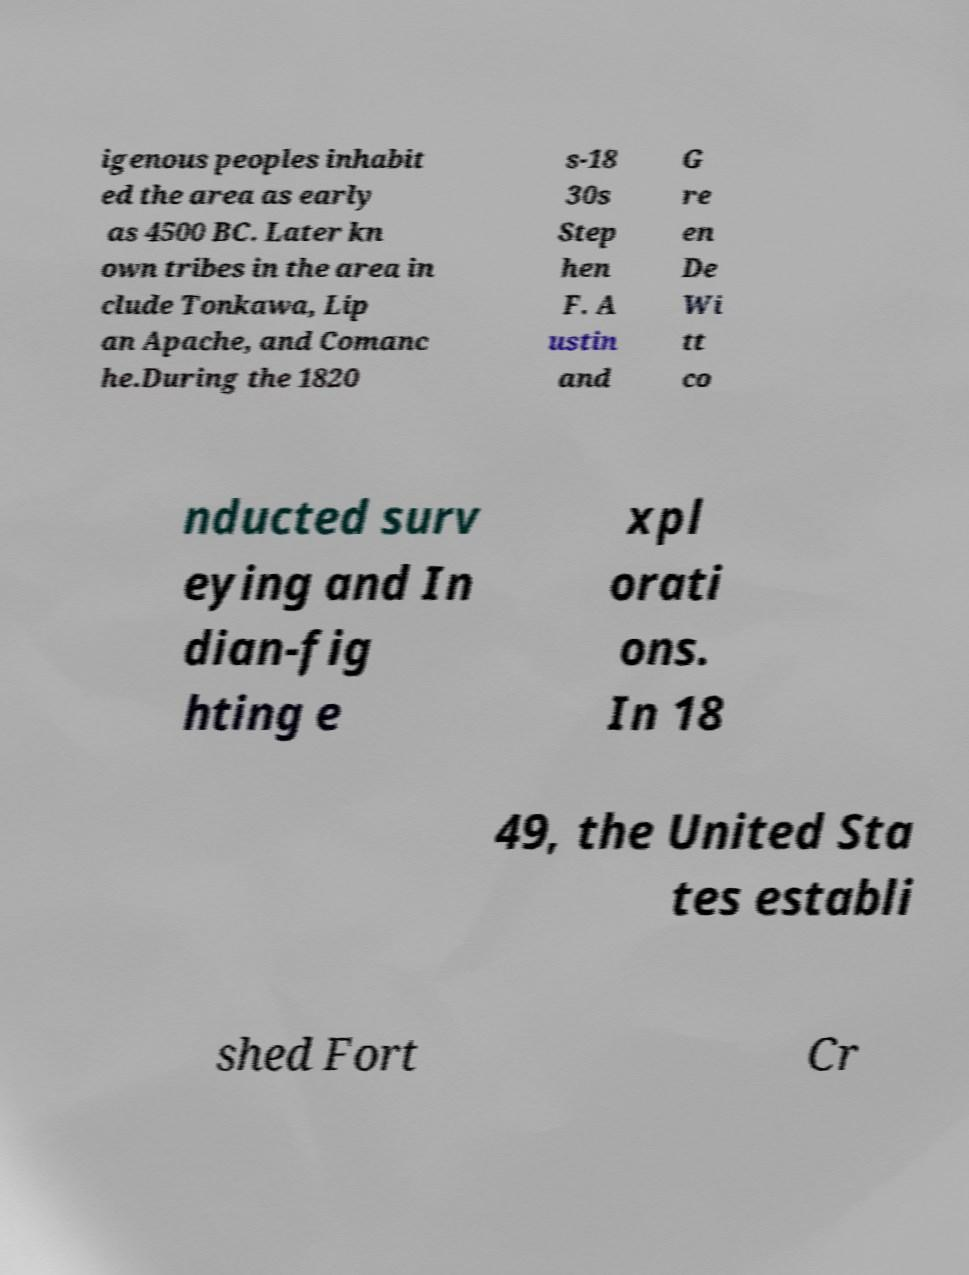Can you read and provide the text displayed in the image?This photo seems to have some interesting text. Can you extract and type it out for me? igenous peoples inhabit ed the area as early as 4500 BC. Later kn own tribes in the area in clude Tonkawa, Lip an Apache, and Comanc he.During the 1820 s-18 30s Step hen F. A ustin and G re en De Wi tt co nducted surv eying and In dian-fig hting e xpl orati ons. In 18 49, the United Sta tes establi shed Fort Cr 